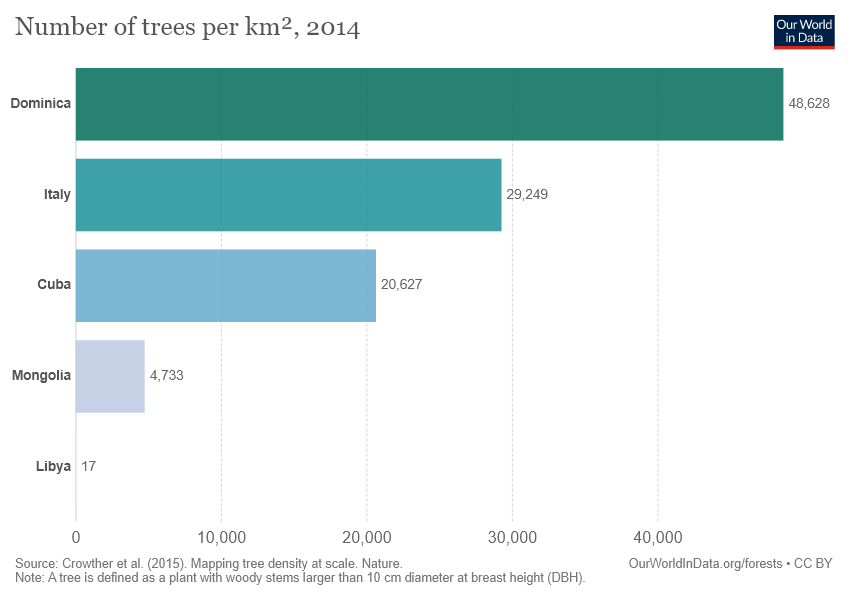Draw attention to some important aspects in this diagram. Libya is the place that exhibits the value of 17. The value difference between Italy and Cuba is 8,622. 